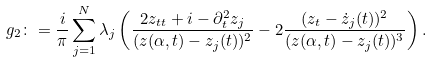Convert formula to latex. <formula><loc_0><loc_0><loc_500><loc_500>g _ { 2 } \colon = \frac { i } { \pi } \sum _ { j = 1 } ^ { N } \lambda _ { j } \left ( \frac { 2 z _ { t t } + i - \partial _ { t } ^ { 2 } z _ { j } } { ( z ( \alpha , t ) - z _ { j } ( t ) ) ^ { 2 } } - 2 \frac { ( z _ { t } - \dot { z } _ { j } ( t ) ) ^ { 2 } } { ( z ( \alpha , t ) - z _ { j } ( t ) ) ^ { 3 } } \right ) .</formula> 